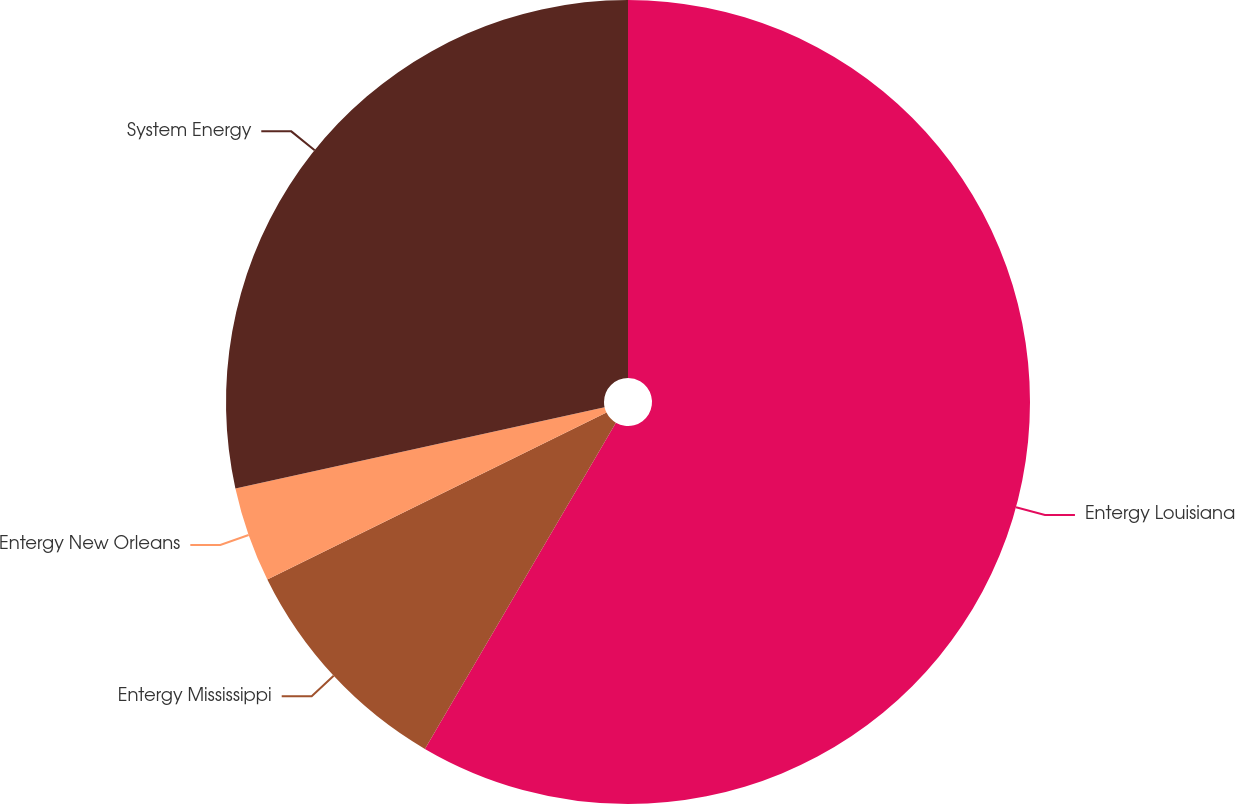Convert chart to OTSL. <chart><loc_0><loc_0><loc_500><loc_500><pie_chart><fcel>Entergy Louisiana<fcel>Entergy Mississippi<fcel>Entergy New Orleans<fcel>System Energy<nl><fcel>58.43%<fcel>9.29%<fcel>3.83%<fcel>28.45%<nl></chart> 